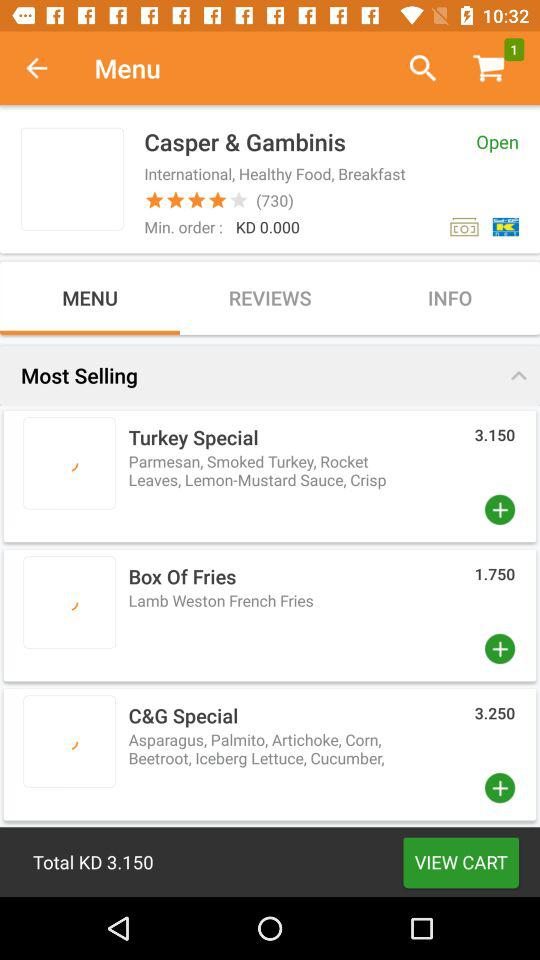What is the price of a box of fries? The price is 1.75. 